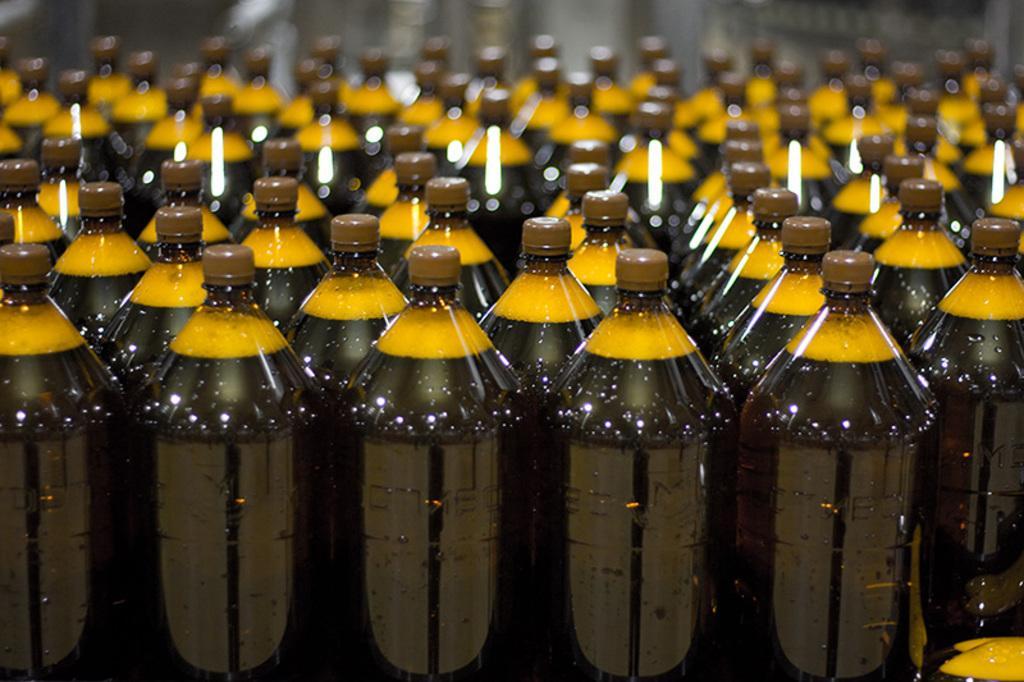Can you describe this image briefly? In this image I see number of bottles, in which the liquid is in black in color and the foam is yellow in color and I see the cap it is brown in color. 